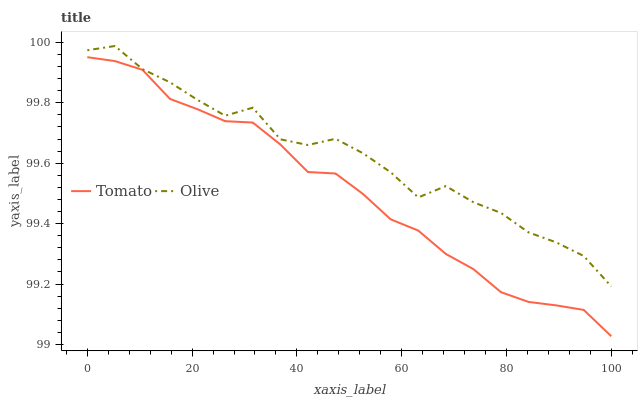Does Olive have the minimum area under the curve?
Answer yes or no. No. Is Olive the smoothest?
Answer yes or no. No. Does Olive have the lowest value?
Answer yes or no. No. Is Tomato less than Olive?
Answer yes or no. Yes. Is Olive greater than Tomato?
Answer yes or no. Yes. Does Tomato intersect Olive?
Answer yes or no. No. 